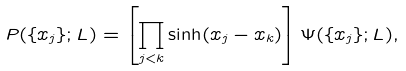<formula> <loc_0><loc_0><loc_500><loc_500>P ( \{ x _ { j } \} ; L ) = \left [ \prod _ { j < k } \sinh ( x _ { j } - x _ { k } ) \right ] \Psi ( \{ x _ { j } \} ; L ) ,</formula> 